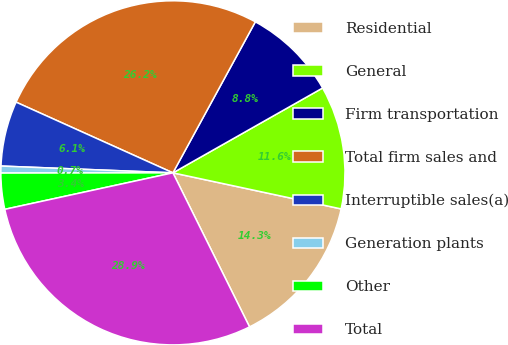<chart> <loc_0><loc_0><loc_500><loc_500><pie_chart><fcel>Residential<fcel>General<fcel>Firm transportation<fcel>Total firm sales and<fcel>Interruptible sales(a)<fcel>Generation plants<fcel>Other<fcel>Total<nl><fcel>14.29%<fcel>11.57%<fcel>8.84%<fcel>26.21%<fcel>6.11%<fcel>0.65%<fcel>3.38%<fcel>28.94%<nl></chart> 